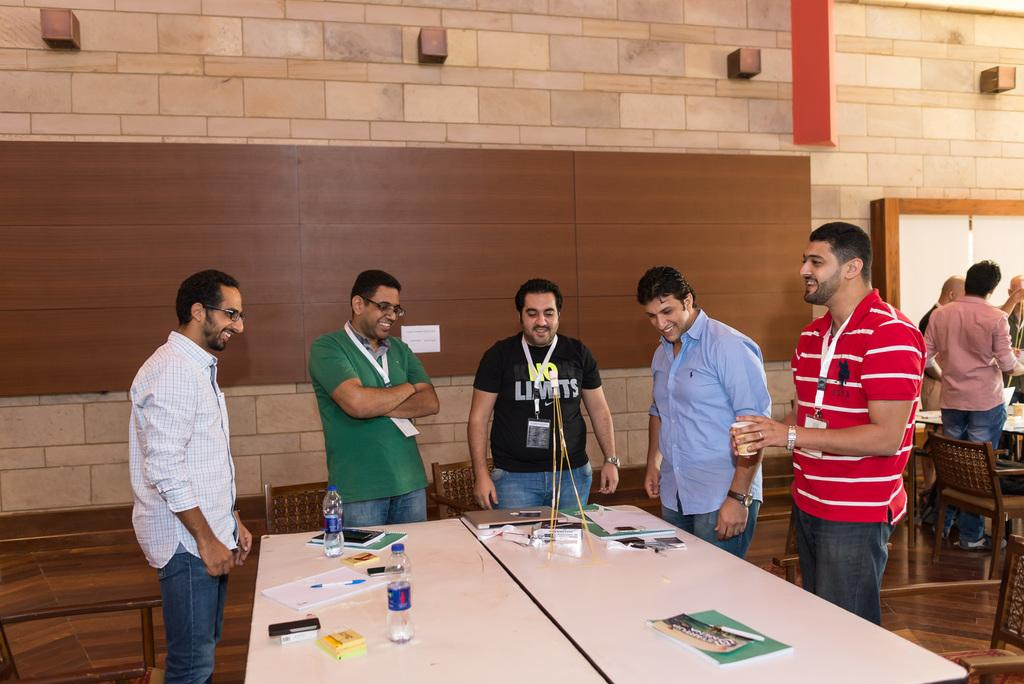What is happening in the foreground of the image? There are people standing in front of the table. What objects can be seen on the table? There are books and bottles on the table. What can be seen in the background of the image? There is a wall in the background of the image. What type of neck can be seen on the people in the image? There is no mention of necks or any specific details about the people's appearance in the image. Can you describe the harbor visible in the image? There is no harbor present in the image; it features people standing in front of a table with books and bottles. 